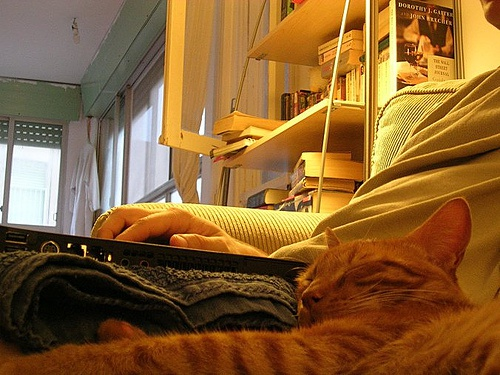Describe the objects in this image and their specific colors. I can see cat in gray, maroon, brown, and black tones, people in gray, brown, maroon, and orange tones, book in gray, maroon, orange, and brown tones, laptop in gray, black, maroon, and olive tones, and book in gray, brown, maroon, orange, and gold tones in this image. 